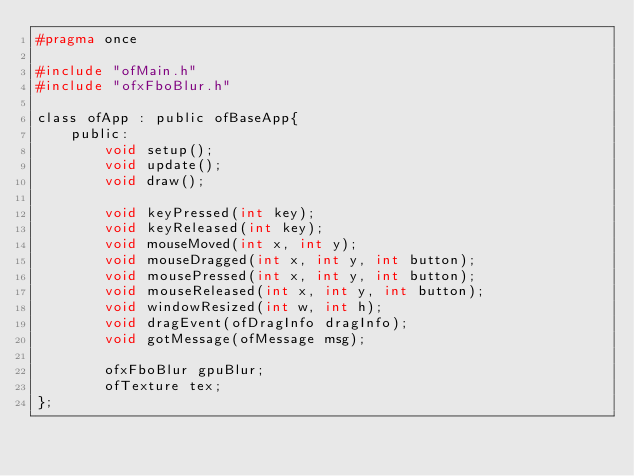Convert code to text. <code><loc_0><loc_0><loc_500><loc_500><_C_>#pragma once

#include "ofMain.h"
#include "ofxFboBlur.h"

class ofApp : public ofBaseApp{
	public:
		void setup();
		void update();
		void draw();
		
		void keyPressed(int key);
		void keyReleased(int key);
		void mouseMoved(int x, int y);
		void mouseDragged(int x, int y, int button);
		void mousePressed(int x, int y, int button);
		void mouseReleased(int x, int y, int button);
		void windowResized(int w, int h);
		void dragEvent(ofDragInfo dragInfo);
		void gotMessage(ofMessage msg);

		ofxFboBlur gpuBlur;
		ofTexture tex;
};
</code> 